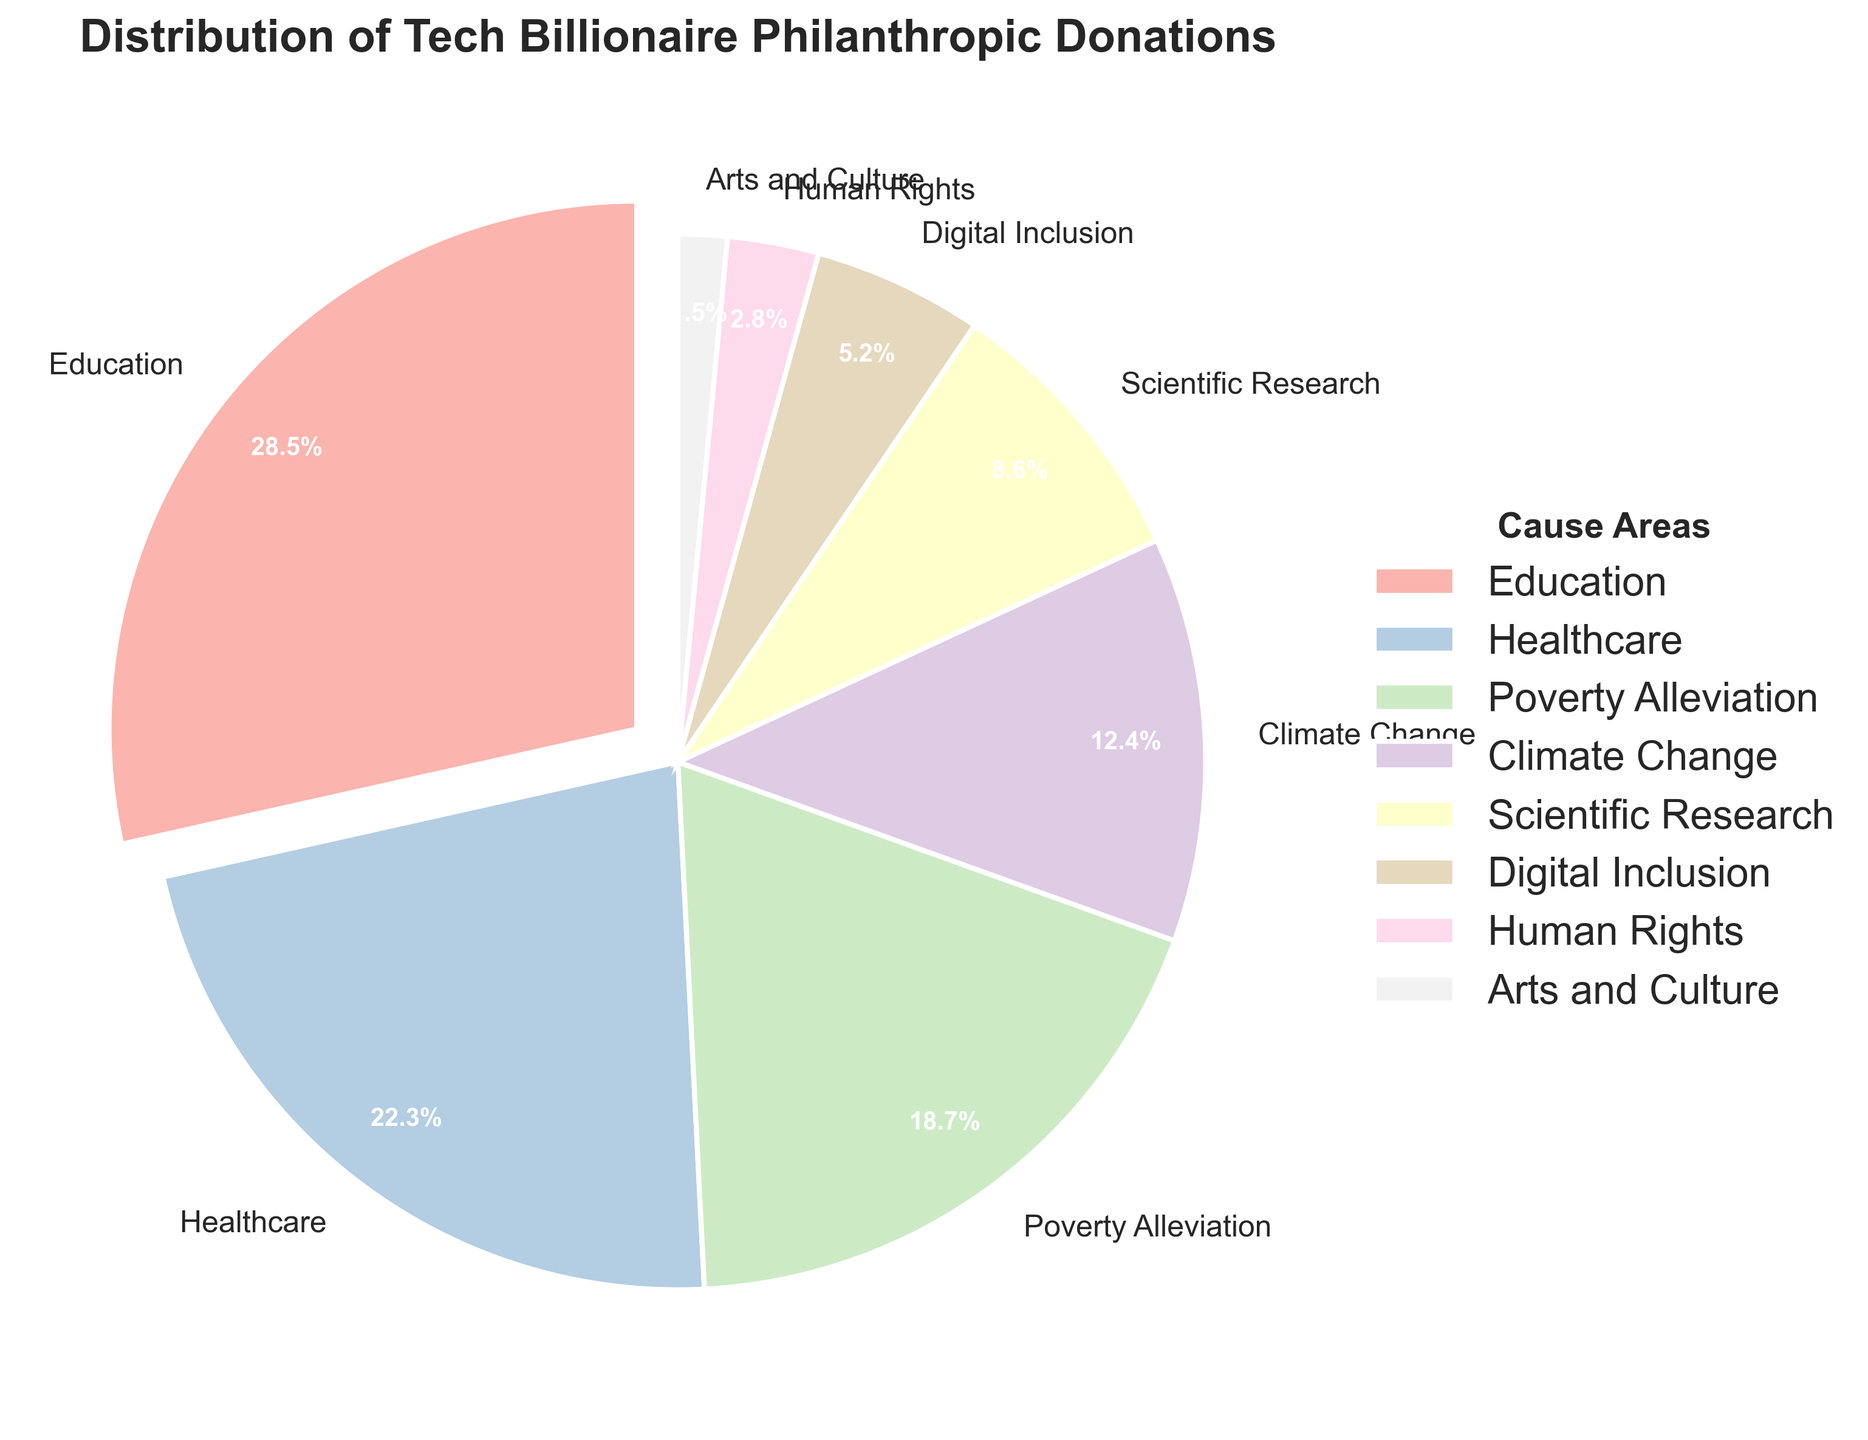What cause area receives the highest percentage of donations? The slice of the pie chart with the largest percentage label belongs to Education. The exploded slice also helps identify it as receiving 28.5% of donations.
Answer: Education Which cause area receives more donations: Healthcare or Scientific Research? By examining their respective slices on the pie chart, Healthcare receives 22.3% and Scientific Research receives 8.6%. Since 22.3% is greater than 8.6%, Healthcare receives more donations.
Answer: Healthcare How much more percentage does Poverty Alleviation receive compared to Climate Change? Poverty Alleviation receives 18.7%, and Climate Change receives 12.4%. The difference is calculated as 18.7% - 12.4%. So, Poverty Alleviation receives 6.3% more donations compared to Climate Change.
Answer: 6.3% What is the combined percentage of donations to Education, Healthcare, and Digital Inclusion? By summing the percentages for Education (28.5%), Healthcare (22.3%), and Digital Inclusion (5.2%), the combined percentage is 28.5% + 22.3% + 5.2%. This results in 56.0%.
Answer: 56.0% Which cause area receives the least amount of donations? Examining the smallest slice of the pie chart, Arts and Culture receives the lowest percentage of donations at 1.5%.
Answer: Arts and Culture Are there any cause areas receiving exactly equal percentages? By examining each slice's percentage value, no two cause areas have identical percentages.
Answer: No What percentage of donations do Climate Change and Human Rights receive combined? By summing the percentages for Climate Change (12.4%) and Human Rights (2.8%), the combined percentage is 12.4% + 2.8%. This equals 15.2%.
Answer: 15.2% What is the difference in donation percentage between Digital Inclusion and Human Rights? Digital Inclusion receives 5.2%, and Human Rights receives 2.8%. The difference is calculated as 5.2% - 2.8%, which equals 2.4%.
Answer: 2.4% Which cause areas receive more than 20% of the total donations? By examining the pie chart, Education (28.5%) and Healthcare (22.3%) are the only cause areas receiving more than 20% each.
Answer: Education, Healthcare 